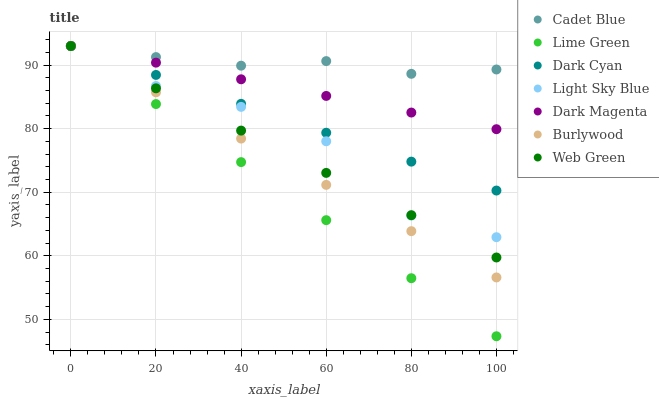Does Lime Green have the minimum area under the curve?
Answer yes or no. Yes. Does Cadet Blue have the maximum area under the curve?
Answer yes or no. Yes. Does Dark Magenta have the minimum area under the curve?
Answer yes or no. No. Does Dark Magenta have the maximum area under the curve?
Answer yes or no. No. Is Dark Magenta the smoothest?
Answer yes or no. Yes. Is Light Sky Blue the roughest?
Answer yes or no. Yes. Is Burlywood the smoothest?
Answer yes or no. No. Is Burlywood the roughest?
Answer yes or no. No. Does Lime Green have the lowest value?
Answer yes or no. Yes. Does Dark Magenta have the lowest value?
Answer yes or no. No. Does Lime Green have the highest value?
Answer yes or no. Yes. Does Cadet Blue intersect Light Sky Blue?
Answer yes or no. Yes. Is Cadet Blue less than Light Sky Blue?
Answer yes or no. No. Is Cadet Blue greater than Light Sky Blue?
Answer yes or no. No. 